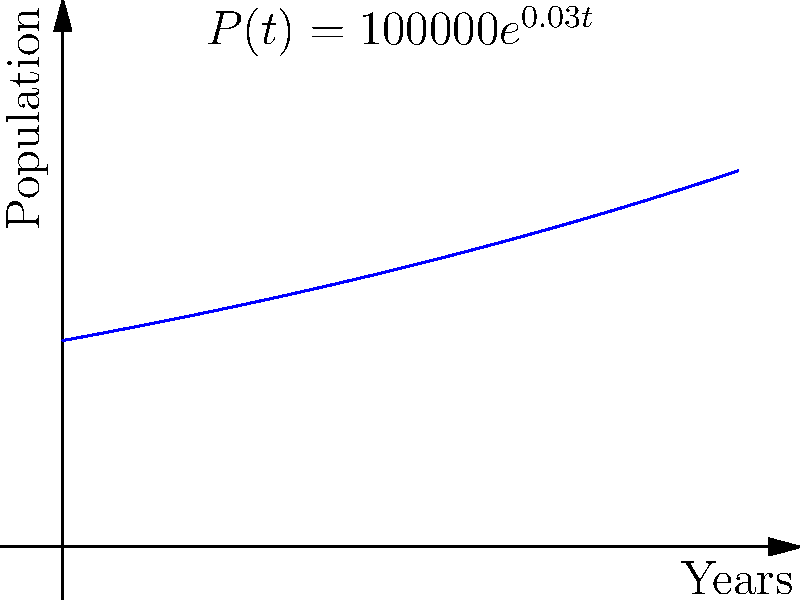The graph shows the population growth of a city over time, modeled by the function $P(t) = 100000e^{0.03t}$, where $P$ is the population and $t$ is time in years. As an urban development planner, you need to determine the rate of population growth at $t=10$ years. What is the population growth rate at this time? To find the population growth rate at $t=10$ years, we need to follow these steps:

1) The population growth rate is given by the derivative of the population function:
   $\frac{dP}{dt} = \frac{d}{dt}(100000e^{0.03t})$

2) Using the chain rule:
   $\frac{dP}{dt} = 100000 \cdot 0.03 \cdot e^{0.03t}$

3) Simplify:
   $\frac{dP}{dt} = 3000e^{0.03t}$

4) To find the growth rate at $t=10$, substitute $t=10$ into this equation:
   $\frac{dP}{dt}|_{t=10} = 3000e^{0.03(10)}$

5) Calculate:
   $\frac{dP}{dt}|_{t=10} = 3000e^{0.3} \approx 4049.58$

This means the population is growing at a rate of approximately 4050 people per year at $t=10$ years.
Answer: 4050 people/year 